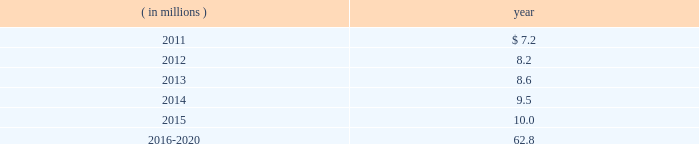The company expects to amortize $ 1.7 million of actuarial loss from accumulated other comprehensive income ( loss ) into net periodic benefit costs in 2011 .
At december 31 , 2010 , anticipated benefit payments from the plan in future years are as follows: .
Savings plans .
Cme maintains a defined contribution savings plan pursuant to section 401 ( k ) of the internal revenue code , whereby all u.s .
Employees are participants and have the option to contribute to this plan .
Cme matches employee contributions up to 3% ( 3 % ) of the employee 2019s base salary and may make additional discretionary contributions of up to 2% ( 2 % ) of base salary .
In addition , certain cme london-based employees are eligible to participate in a defined contribution plan .
For cme london-based employees , the plan provides for company contributions of 10% ( 10 % ) of earnings and does not have any vesting requirements .
Salary and cash bonuses paid are included in the definition of earnings .
Aggregate expense for all of the defined contribution savings plans amounted to $ 6.3 million , $ 5.2 million and $ 5.8 million in 2010 , 2009 and 2008 , respectively .
Cme non-qualified plans .
Cme maintains non-qualified plans , under which participants may make assumed investment choices with respect to amounts contributed on their behalf .
Although not required to do so , cme invests such contributions in assets that mirror the assumed investment choices .
The balances in these plans are subject to the claims of general creditors of the exchange and totaled $ 28.8 million and $ 23.4 million at december 31 , 2010 and 2009 , respectively .
Although the value of the plans is recorded as an asset in the consolidated balance sheets , there is an equal and offsetting liability .
The investment results of these plans have no impact on net income as the investment results are recorded in equal amounts to both investment income and compensation and benefits expense .
Supplemental savings plan 2014cme maintains a supplemental plan to provide benefits for employees who have been impacted by statutory limits under the provisions of the qualified pension and savings plan .
All cme employees hired prior to january 1 , 2007 are immediately vested in their supplemental plan benefits .
All cme employees hired on or after january 1 , 2007 are subject to the vesting requirements of the underlying qualified plans .
Total expense for the supplemental plan was $ 0.9 million , $ 0.7 million and $ 1.3 million for 2010 , 2009 and 2008 , respectively .
Deferred compensation plan 2014a deferred compensation plan is maintained by cme , under which eligible officers and members of the board of directors may contribute a percentage of their compensation and defer income taxes thereon until the time of distribution .
Nymexmembers 2019 retirement plan and benefits .
Nymex maintained a retirement and benefit plan under the commodities exchange , inc .
( comex ) members 2019 recognition and retention plan ( mrrp ) .
This plan provides benefits to certain members of the comex division based on long-term membership , and participation is limited to individuals who were comex division members prior to nymex 2019s acquisition of comex in 1994 .
No new participants were permitted into the plan after the date of this acquisition .
Under the terms of the mrrp , the company is required to fund the plan with a minimum annual contribution of $ 0.4 million until it is fully funded .
All benefits to be paid under the mrrp are based on reasonable actuarial assumptions which are based upon the amounts that are available and are expected to be available to pay benefits .
Total contributions to the plan were $ 0.8 million for each of 2010 , 2009 and for the period august 23 through december 31 , 2008 .
At december 31 , 2010 and 2009 , the total obligation for the mrrp totaled $ 20.7 million and $ 20.5 million .
At december 31 , 2010 , what was the ratio of the anticipated benefit payments from the plan in future for 2015 to 2016-2020? 
Computations: (62.8 / 10)
Answer: 6.28. 